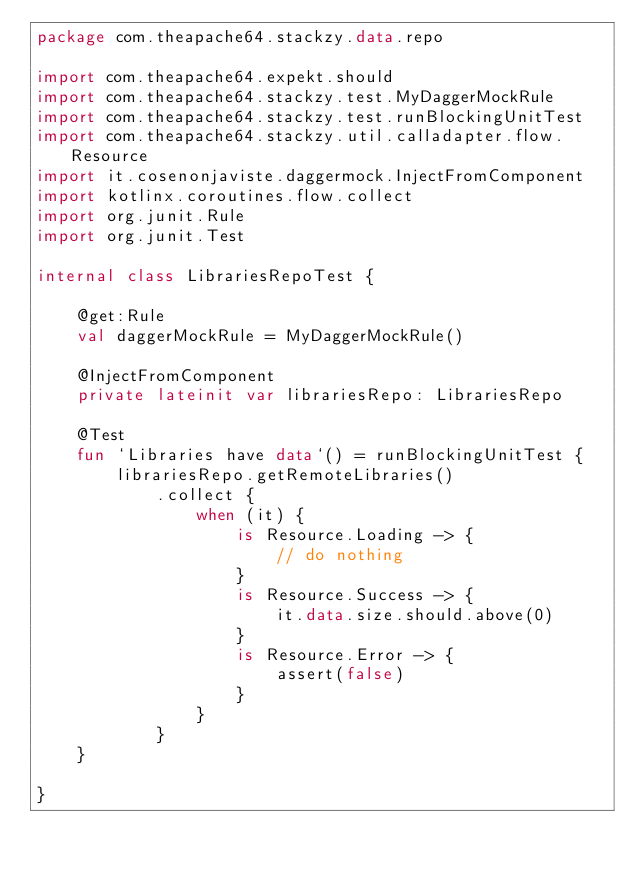Convert code to text. <code><loc_0><loc_0><loc_500><loc_500><_Kotlin_>package com.theapache64.stackzy.data.repo

import com.theapache64.expekt.should
import com.theapache64.stackzy.test.MyDaggerMockRule
import com.theapache64.stackzy.test.runBlockingUnitTest
import com.theapache64.stackzy.util.calladapter.flow.Resource
import it.cosenonjaviste.daggermock.InjectFromComponent
import kotlinx.coroutines.flow.collect
import org.junit.Rule
import org.junit.Test

internal class LibrariesRepoTest {

    @get:Rule
    val daggerMockRule = MyDaggerMockRule()

    @InjectFromComponent
    private lateinit var librariesRepo: LibrariesRepo

    @Test
    fun `Libraries have data`() = runBlockingUnitTest {
        librariesRepo.getRemoteLibraries()
            .collect {
                when (it) {
                    is Resource.Loading -> {
                        // do nothing
                    }
                    is Resource.Success -> {
                        it.data.size.should.above(0)
                    }
                    is Resource.Error -> {
                        assert(false)
                    }
                }
            }
    }

}</code> 